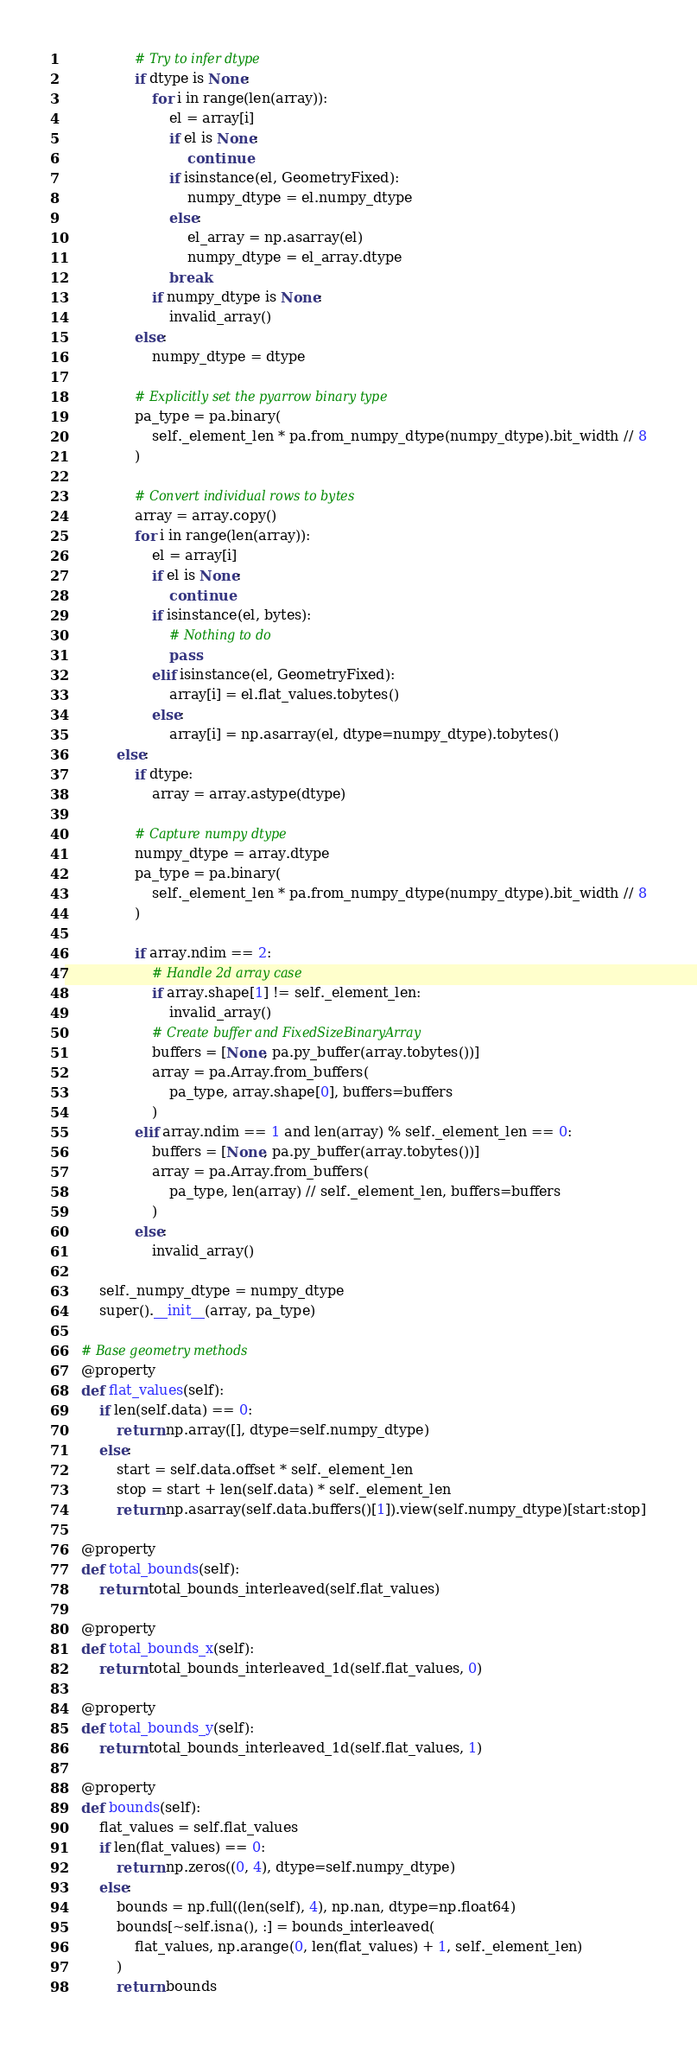<code> <loc_0><loc_0><loc_500><loc_500><_Python_>                # Try to infer dtype
                if dtype is None:
                    for i in range(len(array)):
                        el = array[i]
                        if el is None:
                            continue
                        if isinstance(el, GeometryFixed):
                            numpy_dtype = el.numpy_dtype
                        else:
                            el_array = np.asarray(el)
                            numpy_dtype = el_array.dtype
                        break
                    if numpy_dtype is None:
                        invalid_array()
                else:
                    numpy_dtype = dtype

                # Explicitly set the pyarrow binary type
                pa_type = pa.binary(
                    self._element_len * pa.from_numpy_dtype(numpy_dtype).bit_width // 8
                )

                # Convert individual rows to bytes
                array = array.copy()
                for i in range(len(array)):
                    el = array[i]
                    if el is None:
                        continue
                    if isinstance(el, bytes):
                        # Nothing to do
                        pass
                    elif isinstance(el, GeometryFixed):
                        array[i] = el.flat_values.tobytes()
                    else:
                        array[i] = np.asarray(el, dtype=numpy_dtype).tobytes()
            else:
                if dtype:
                    array = array.astype(dtype)

                # Capture numpy dtype
                numpy_dtype = array.dtype
                pa_type = pa.binary(
                    self._element_len * pa.from_numpy_dtype(numpy_dtype).bit_width // 8
                )

                if array.ndim == 2:
                    # Handle 2d array case
                    if array.shape[1] != self._element_len:
                        invalid_array()
                    # Create buffer and FixedSizeBinaryArray
                    buffers = [None, pa.py_buffer(array.tobytes())]
                    array = pa.Array.from_buffers(
                        pa_type, array.shape[0], buffers=buffers
                    )
                elif array.ndim == 1 and len(array) % self._element_len == 0:
                    buffers = [None, pa.py_buffer(array.tobytes())]
                    array = pa.Array.from_buffers(
                        pa_type, len(array) // self._element_len, buffers=buffers
                    )
                else:
                    invalid_array()

        self._numpy_dtype = numpy_dtype
        super().__init__(array, pa_type)

    # Base geometry methods
    @property
    def flat_values(self):
        if len(self.data) == 0:
            return np.array([], dtype=self.numpy_dtype)
        else:
            start = self.data.offset * self._element_len
            stop = start + len(self.data) * self._element_len
            return np.asarray(self.data.buffers()[1]).view(self.numpy_dtype)[start:stop]

    @property
    def total_bounds(self):
        return total_bounds_interleaved(self.flat_values)

    @property
    def total_bounds_x(self):
        return total_bounds_interleaved_1d(self.flat_values, 0)

    @property
    def total_bounds_y(self):
        return total_bounds_interleaved_1d(self.flat_values, 1)

    @property
    def bounds(self):
        flat_values = self.flat_values
        if len(flat_values) == 0:
            return np.zeros((0, 4), dtype=self.numpy_dtype)
        else:
            bounds = np.full((len(self), 4), np.nan, dtype=np.float64)
            bounds[~self.isna(), :] = bounds_interleaved(
                flat_values, np.arange(0, len(flat_values) + 1, self._element_len)
            )
            return bounds
</code> 